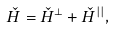<formula> <loc_0><loc_0><loc_500><loc_500>\check { H } = \check { H } ^ { \bot } + \check { H } ^ { | | } , \</formula> 